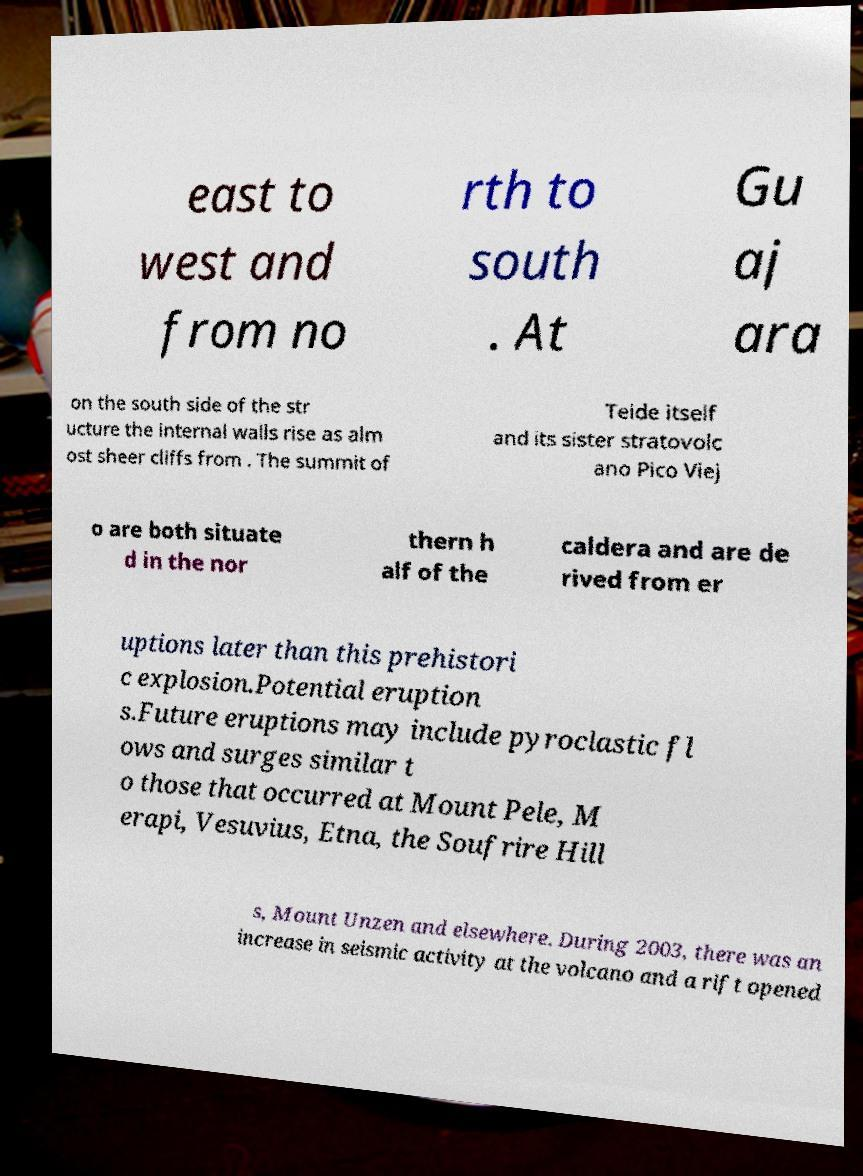I need the written content from this picture converted into text. Can you do that? east to west and from no rth to south . At Gu aj ara on the south side of the str ucture the internal walls rise as alm ost sheer cliffs from . The summit of Teide itself and its sister stratovolc ano Pico Viej o are both situate d in the nor thern h alf of the caldera and are de rived from er uptions later than this prehistori c explosion.Potential eruption s.Future eruptions may include pyroclastic fl ows and surges similar t o those that occurred at Mount Pele, M erapi, Vesuvius, Etna, the Soufrire Hill s, Mount Unzen and elsewhere. During 2003, there was an increase in seismic activity at the volcano and a rift opened 